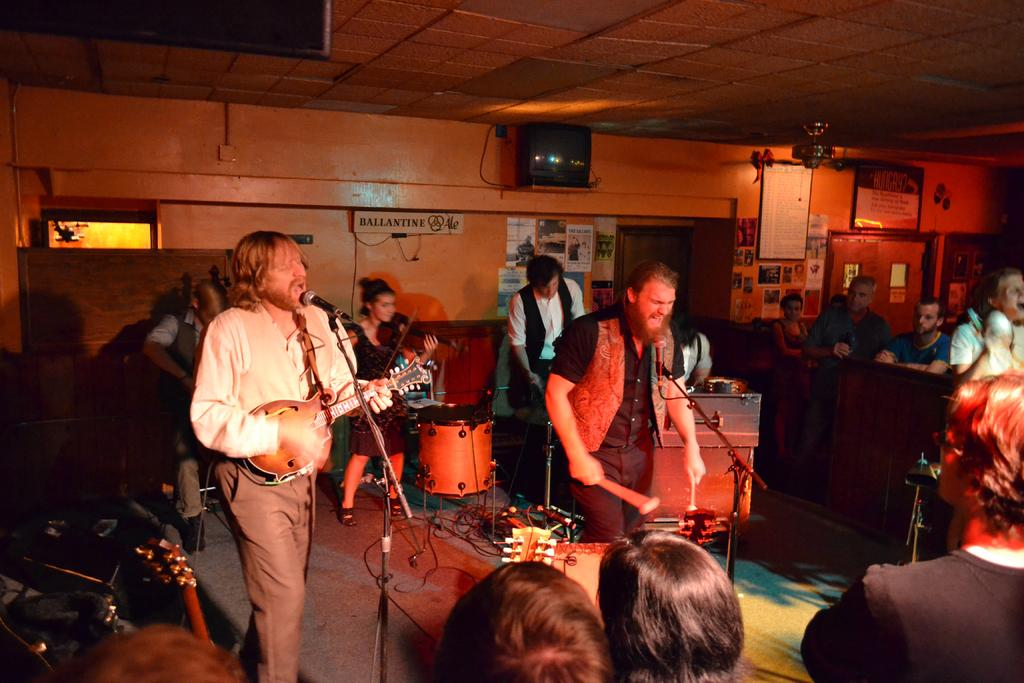What are the people in the image doing? There is a group of people playing music in the image. Who is present to watch the musicians? There is an audience in front of the musicians. How many giants can be seen in the image? There are no giants present in the image. What hobbies do the musicians have outside of playing music? The image does not provide information about the musicians' hobbies outside of playing music. 